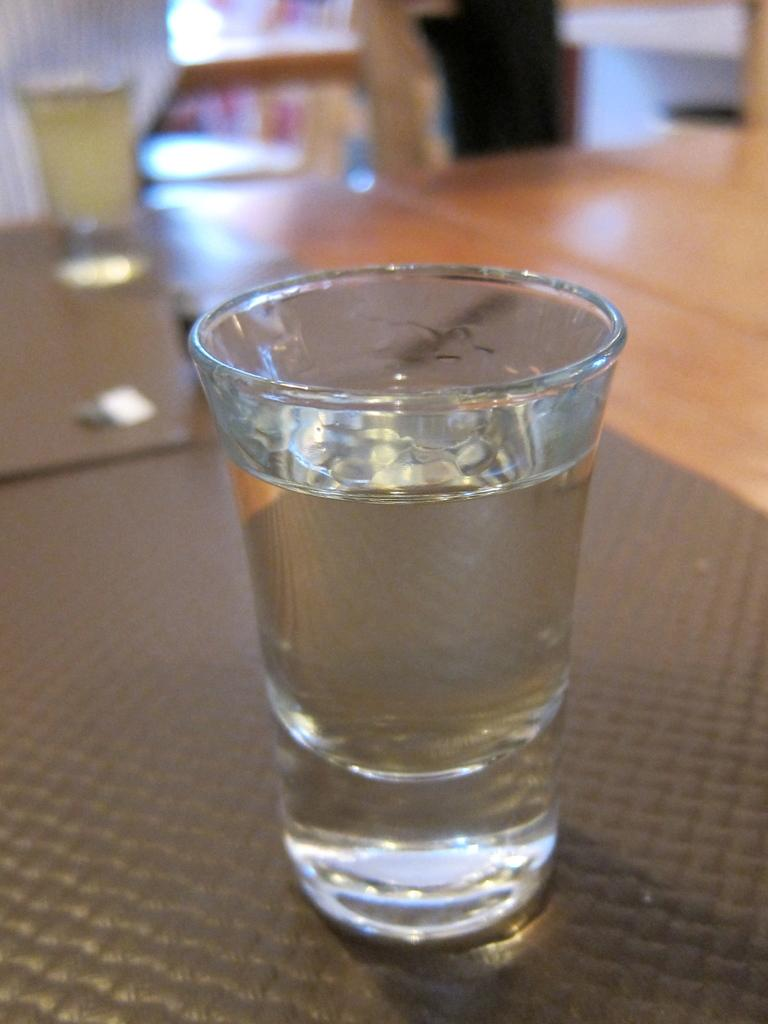What is in the glass that is visible in the image? There is a glass of water in the image. Where is the glass of water located? The glass of water is on a table. Can you describe another glass visible in the image? There is another glass visible glass visible in the image, but it is blurry. What industry is responsible for producing the pain felt by the glass in the image? There is no indication of pain or any industry in the image; it simply shows a glass of water on a table and another blurry glass. 